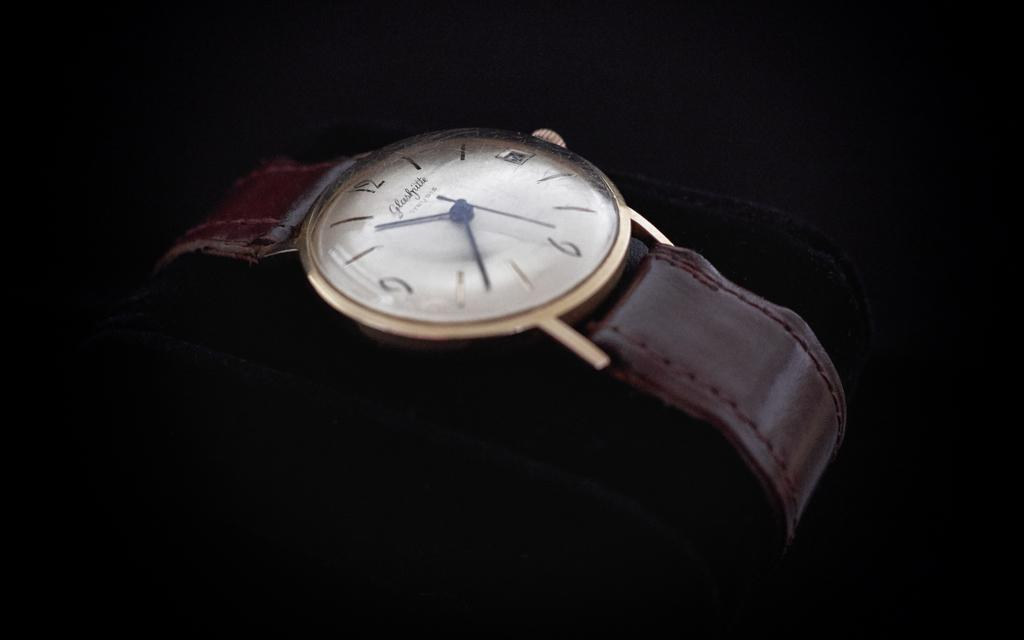<image>
Relay a brief, clear account of the picture shown. A watch with a brown leather band shows 10:38. 